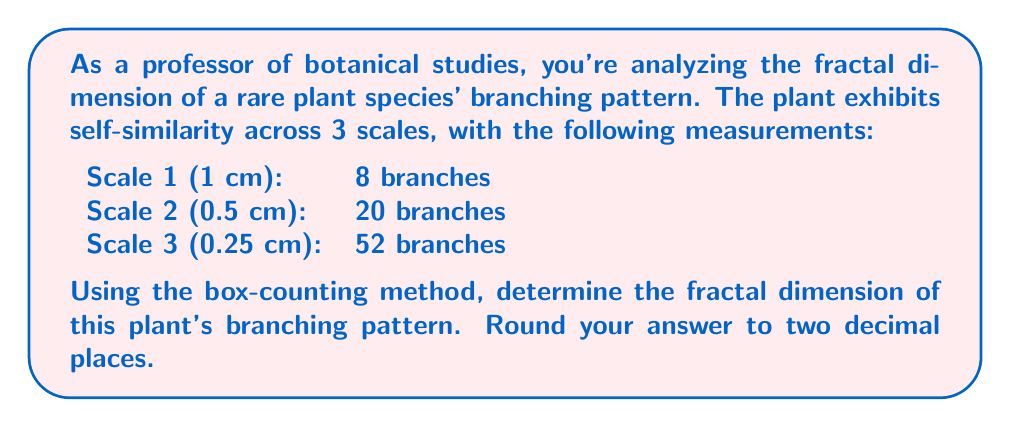Could you help me with this problem? To determine the fractal dimension using the box-counting method, we'll follow these steps:

1) The box-counting dimension is defined as:

   $$D = \lim_{\epsilon \to 0} \frac{\log N(\epsilon)}{\log(1/\epsilon)}$$

   where $N(\epsilon)$ is the number of boxes of side length $\epsilon$ needed to cover the object.

2) We have three scales, so we'll calculate the dimension for each pair and take the average:

   Scale 1 to 2:
   $\epsilon_1 = 1$, $N(\epsilon_1) = 8$
   $\epsilon_2 = 0.5$, $N(\epsilon_2) = 20$

   $$D_{1,2} = \frac{\log(N(\epsilon_2)) - \log(N(\epsilon_1))}{\log(1/\epsilon_2) - \log(1/\epsilon_1)} = \frac{\log(20) - \log(8)}{\log(2) - \log(1)} = \frac{\log(2.5)}{\log(2)} \approx 1.3219$$

   Scale 2 to 3:
   $\epsilon_2 = 0.5$, $N(\epsilon_2) = 20$
   $\epsilon_3 = 0.25$, $N(\epsilon_3) = 52$

   $$D_{2,3} = \frac{\log(N(\epsilon_3)) - \log(N(\epsilon_2))}{\log(1/\epsilon_3) - \log(1/\epsilon_2)} = \frac{\log(52) - \log(20)}{\log(4) - \log(2)} = \frac{\log(2.6)}{\log(2)} \approx 1.3785$$

   Scale 1 to 3:
   $\epsilon_1 = 1$, $N(\epsilon_1) = 8$
   $\epsilon_3 = 0.25$, $N(\epsilon_3) = 52$

   $$D_{1,3} = \frac{\log(N(\epsilon_3)) - \log(N(\epsilon_1))}{\log(1/\epsilon_3) - \log(1/\epsilon_1)} = \frac{\log(52) - \log(8)}{\log(4) - \log(1)} = \frac{\log(6.5)}{\log(4)} \approx 1.3562$$

3) Calculate the average of these three dimensions:

   $$D_{avg} = \frac{D_{1,2} + D_{2,3} + D_{1,3}}{3} = \frac{1.3219 + 1.3785 + 1.3562}{3} \approx 1.3522$$

4) Rounding to two decimal places: 1.35
Answer: The fractal dimension of the plant's branching pattern is approximately 1.35. 